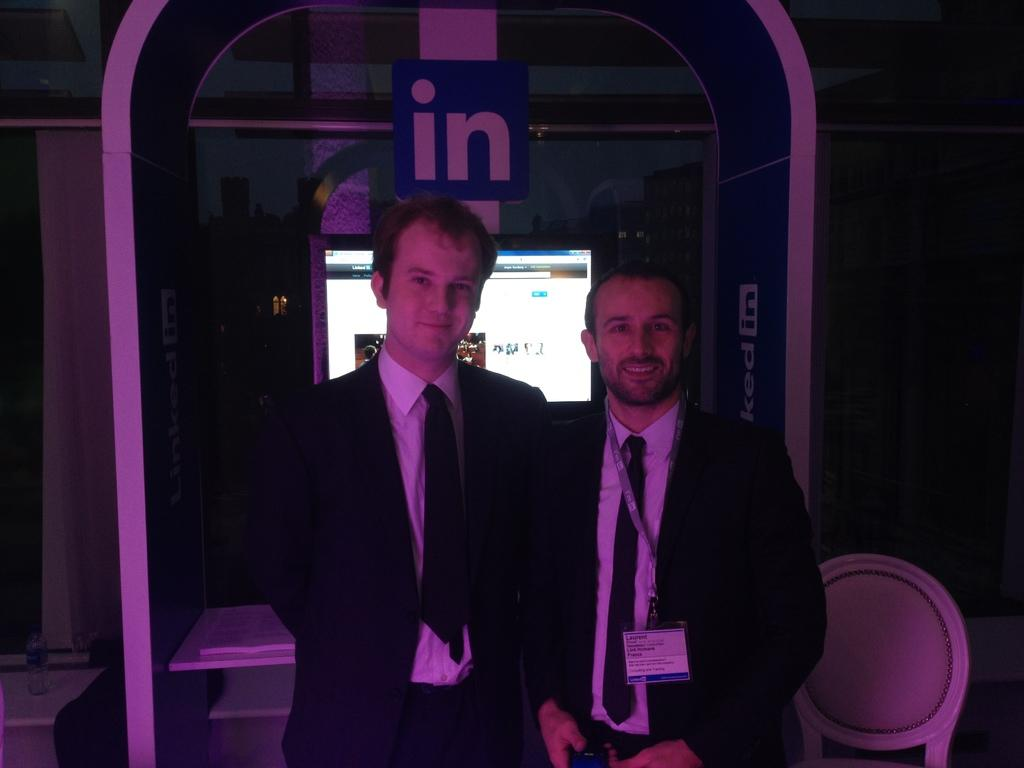How many people are in the image? There are two men in the image. What are the men doing in the image? The men are standing together. What type of clothing are the men wearing? The men are wearing blazers, ties, and shirts. What can be seen in the background of the image? There is a monitor screen visible in the background of the image. What type of tin can be seen in the image? There is no tin present in the image. Who is the owner of the monitor screen in the image? The image does not provide information about the ownership of the monitor screen. 